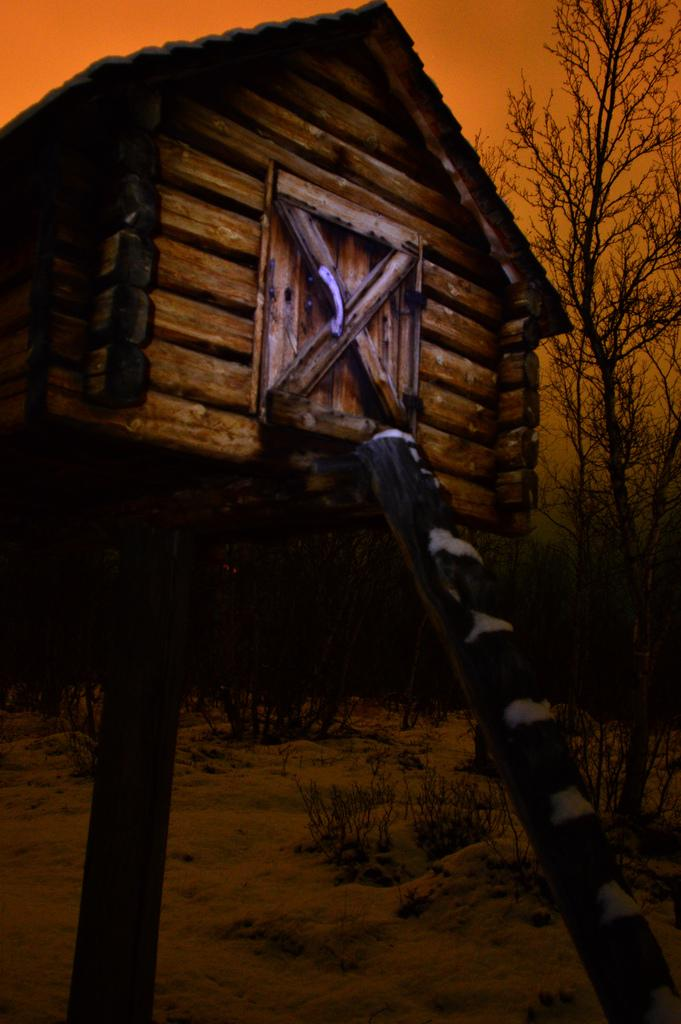What type of house is in the image? There is a wooden house in the image. How is the house elevated from the ground? The house is on poles. What can be used to access the house? There is a ladder in the image. What can be seen in the background of the image? There is a tree visible in the background of the image. How many boys are shaking hands in the image? There are no boys or handshakes present in the image. 